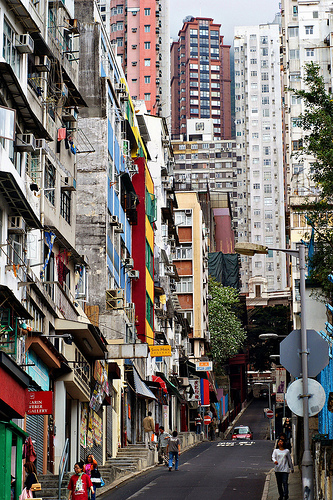<image>
Is there a red building above the yellow building? No. The red building is not positioned above the yellow building. The vertical arrangement shows a different relationship. 